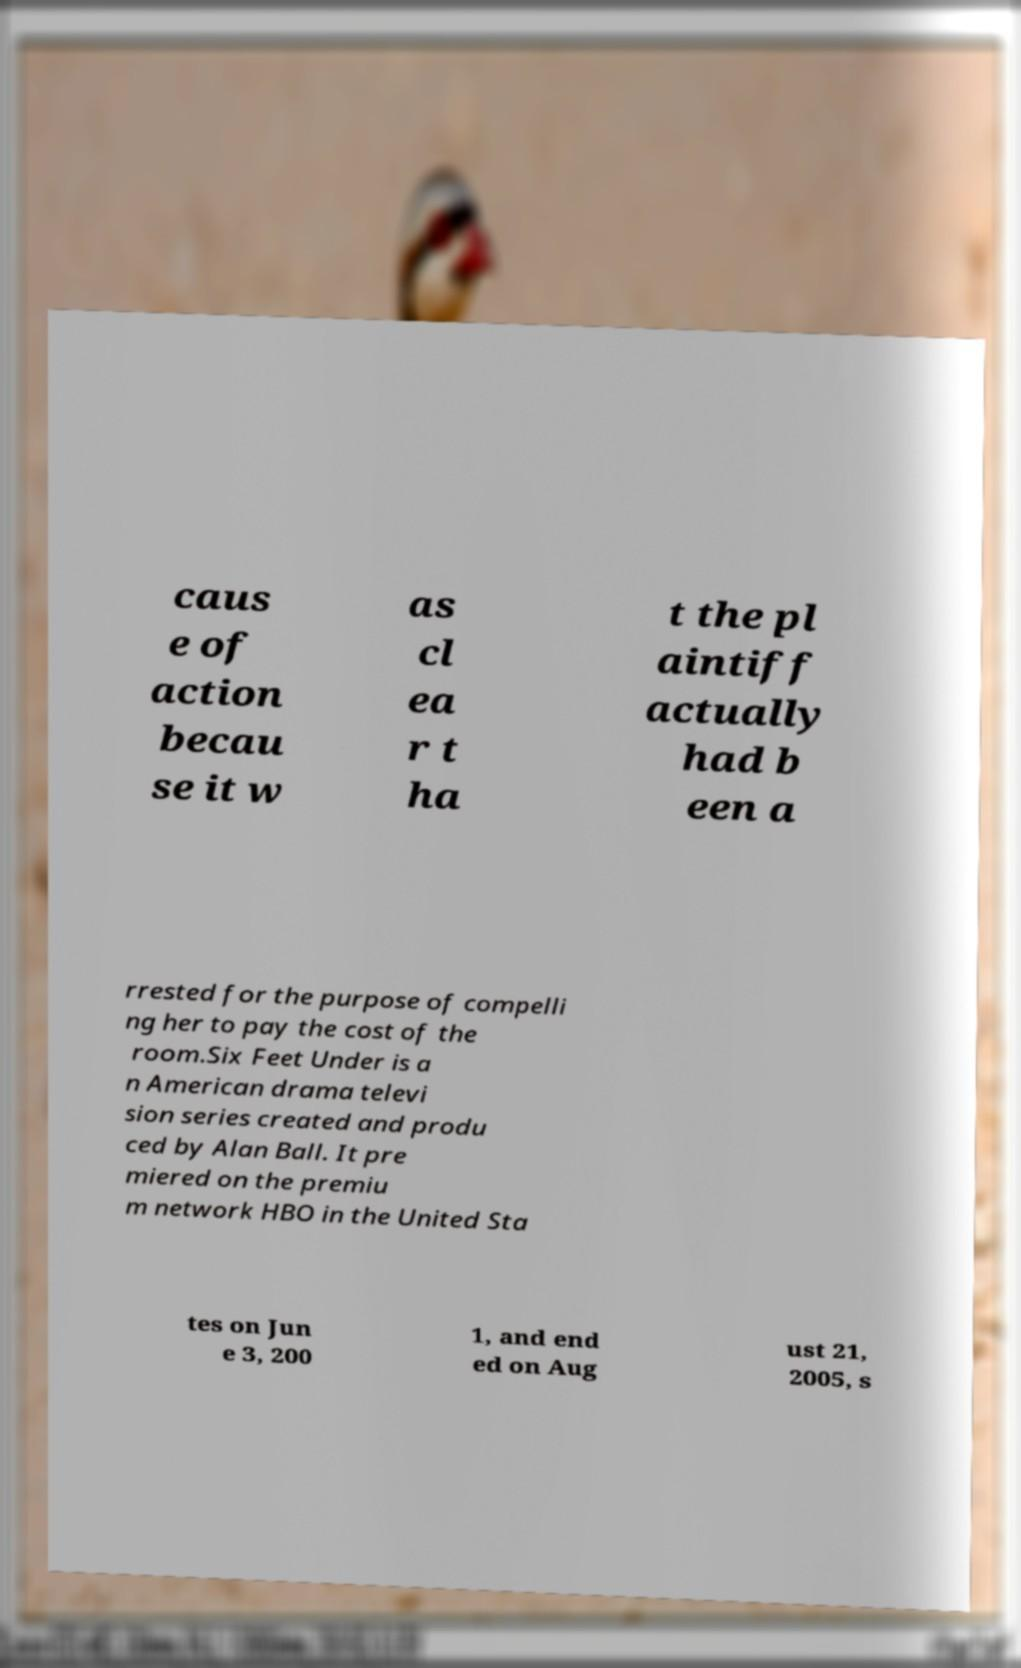I need the written content from this picture converted into text. Can you do that? caus e of action becau se it w as cl ea r t ha t the pl aintiff actually had b een a rrested for the purpose of compelli ng her to pay the cost of the room.Six Feet Under is a n American drama televi sion series created and produ ced by Alan Ball. It pre miered on the premiu m network HBO in the United Sta tes on Jun e 3, 200 1, and end ed on Aug ust 21, 2005, s 